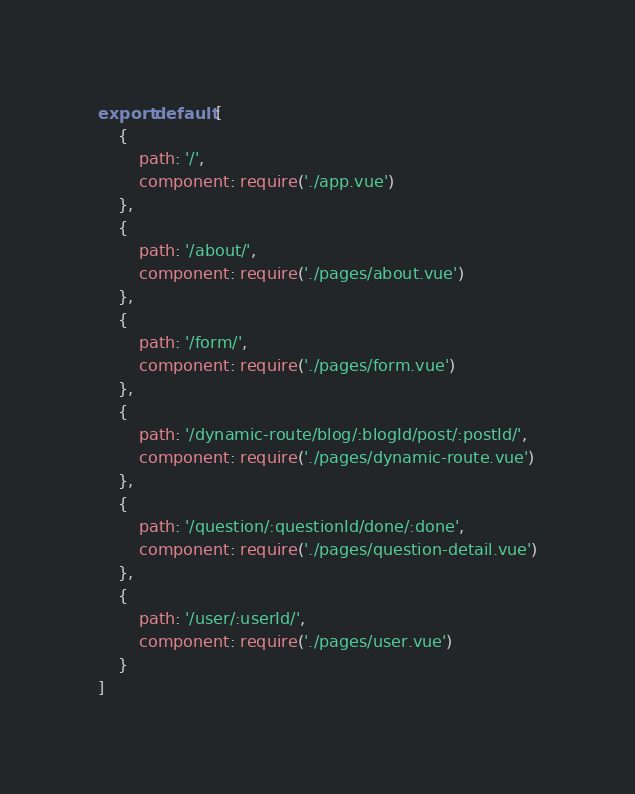<code> <loc_0><loc_0><loc_500><loc_500><_JavaScript_>export default [
    {
        path: '/',
        component: require('./app.vue')
    },
    {
        path: '/about/',
        component: require('./pages/about.vue')
    },
    {
        path: '/form/',
        component: require('./pages/form.vue')
    },
    {
        path: '/dynamic-route/blog/:blogId/post/:postId/',
        component: require('./pages/dynamic-route.vue')
    },
    {
        path: '/question/:questionId/done/:done',
        component: require('./pages/question-detail.vue')
    },
    {
        path: '/user/:userId/',
        component: require('./pages/user.vue')
    }
]
</code> 